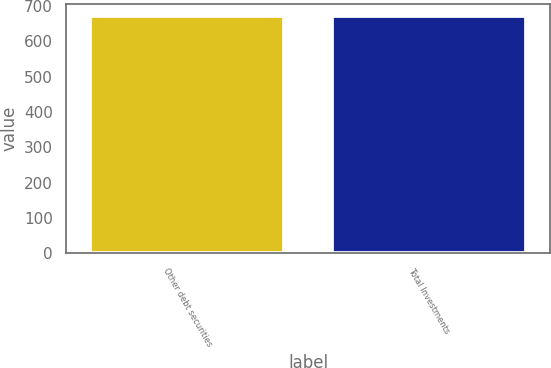Convert chart to OTSL. <chart><loc_0><loc_0><loc_500><loc_500><bar_chart><fcel>Other debt securities<fcel>Total Investments<nl><fcel>672.5<fcel>672.6<nl></chart> 